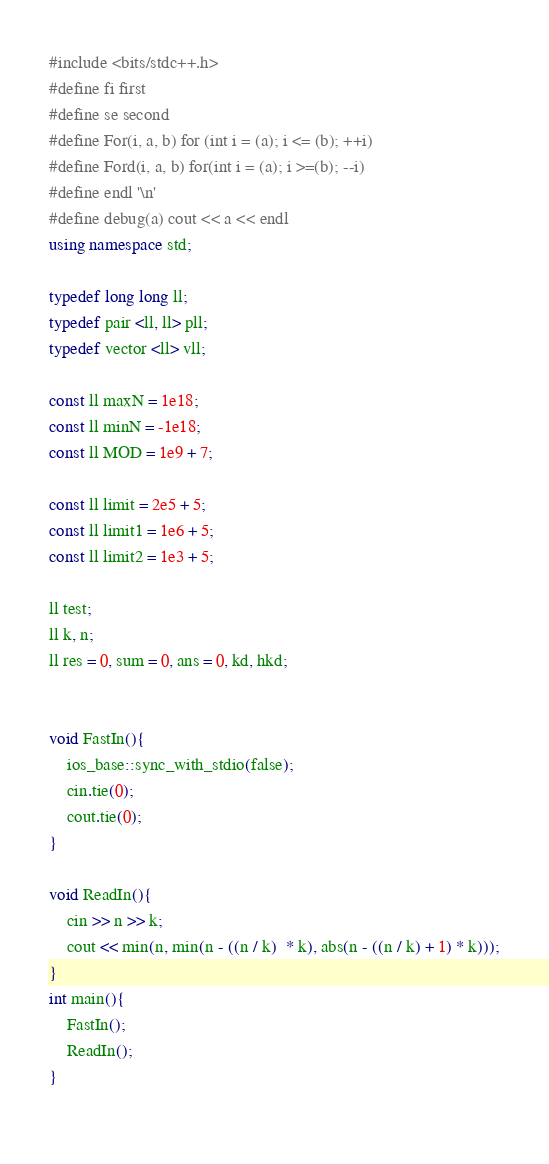<code> <loc_0><loc_0><loc_500><loc_500><_C++_>#include <bits/stdc++.h>
#define fi first
#define se second
#define For(i, a, b) for (int i = (a); i <= (b); ++i)
#define Ford(i, a, b) for(int i = (a); i >=(b); --i)
#define endl '\n'
#define debug(a) cout << a << endl
using namespace std;
 
typedef long long ll;
typedef pair <ll, ll> pll;
typedef vector <ll> vll;
 
const ll maxN = 1e18;
const ll minN = -1e18;
const ll MOD = 1e9 + 7;
 
const ll limit = 2e5 + 5;
const ll limit1 = 1e6 + 5;
const ll limit2 = 1e3 + 5;

ll test;
ll k, n;
ll res = 0, sum = 0, ans = 0, kd, hkd;


void FastIn(){
    ios_base::sync_with_stdio(false);
    cin.tie(0);
    cout.tie(0);
}

void ReadIn(){
    cin >> n >> k;
    cout << min(n, min(n - ((n / k)  * k), abs(n - ((n / k) + 1) * k)));
}
int main(){
    FastIn();
    ReadIn();
}
    </code> 